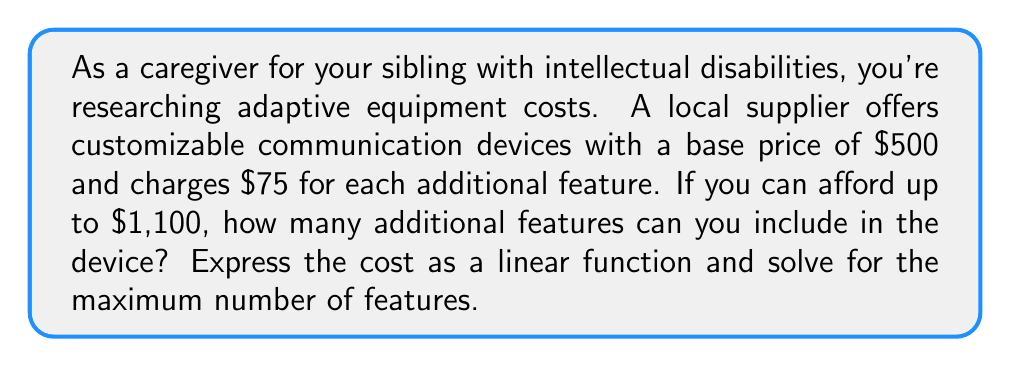Can you answer this question? Let's approach this step-by-step:

1) First, we need to express the cost as a linear function. Let $x$ be the number of additional features, and $y$ be the total cost. The function will be in the form:

   $y = mx + b$

   Where $m$ is the cost per additional feature, and $b$ is the base price.

2) Given the information:
   - Base price (b) = $500
   - Cost per additional feature (m) = $75
   
   So our function is:

   $y = 75x + 500$

3) We want to find the maximum value of $x$ when $y = 1100$ (the maximum affordable cost). We can set up the equation:

   $1100 = 75x + 500$

4) Solve for $x$:
   
   $1100 - 500 = 75x$
   $600 = 75x$
   $x = 600 / 75 = 8$

5) Since we can't have a fractional number of features, we round down to the nearest whole number.

Therefore, you can include 8 additional features while staying within your budget.
Answer: 8 additional features 